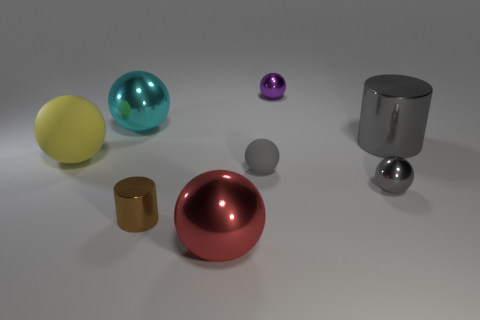What number of things are either rubber things that are to the right of the big red metal sphere or matte objects on the right side of the big yellow ball?
Your answer should be very brief. 1. What number of things are either large metal things or tiny yellow metallic spheres?
Provide a succinct answer. 3. There is a shiny thing that is both to the left of the gray matte object and behind the yellow ball; what size is it?
Your answer should be very brief. Large. What number of small brown things are made of the same material as the brown cylinder?
Make the answer very short. 0. What is the color of the large cylinder that is the same material as the purple ball?
Provide a succinct answer. Gray. Is the color of the small metallic ball that is in front of the large cylinder the same as the small matte thing?
Your response must be concise. Yes. There is a object that is in front of the brown cylinder; what is its material?
Provide a short and direct response. Metal. Are there the same number of gray matte objects that are to the right of the tiny purple shiny sphere and small brown spheres?
Offer a terse response. Yes. How many small metal balls have the same color as the big matte object?
Provide a short and direct response. 0. What color is the other large rubber object that is the same shape as the cyan thing?
Offer a very short reply. Yellow. 